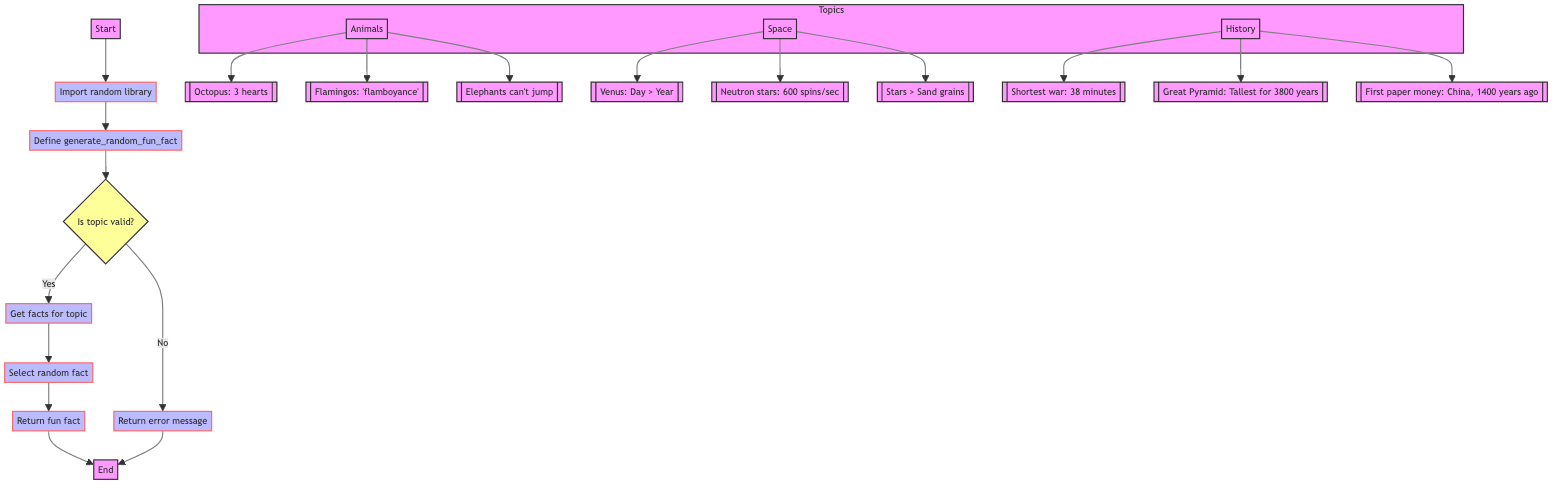What is the starting point of the flowchart? The flowchart starts at node A labeled "Start".
Answer: Start How many different topics are included in the function? There are three different topics: animals, space, and history.
Answer: Three What is returned if the topic is valid? If the topic is valid, the flowchart indicates that a random fun fact is returned.
Answer: Fun fact What action is taken if the provided topic is invalid? If the topic is invalid, the flowchart specifies that an error message is returned.
Answer: Return error message Which library is imported first in the flowchart? The flowchart shows that the random library is imported first.
Answer: Random library How many facts are provided under the topic of space? There are three facts provided for the topic of space in the flowchart.
Answer: Three What is the decision node checking for? The decision node is checking whether the provided topic is valid or not.
Answer: Topic validity What follows the step of selecting a random fact? After selecting a random fact, the flowchart states that the fun fact is returned.
Answer: Return fun fact In which step is the function defined? The function is defined in step C according to the flowchart.
Answer: Define function 